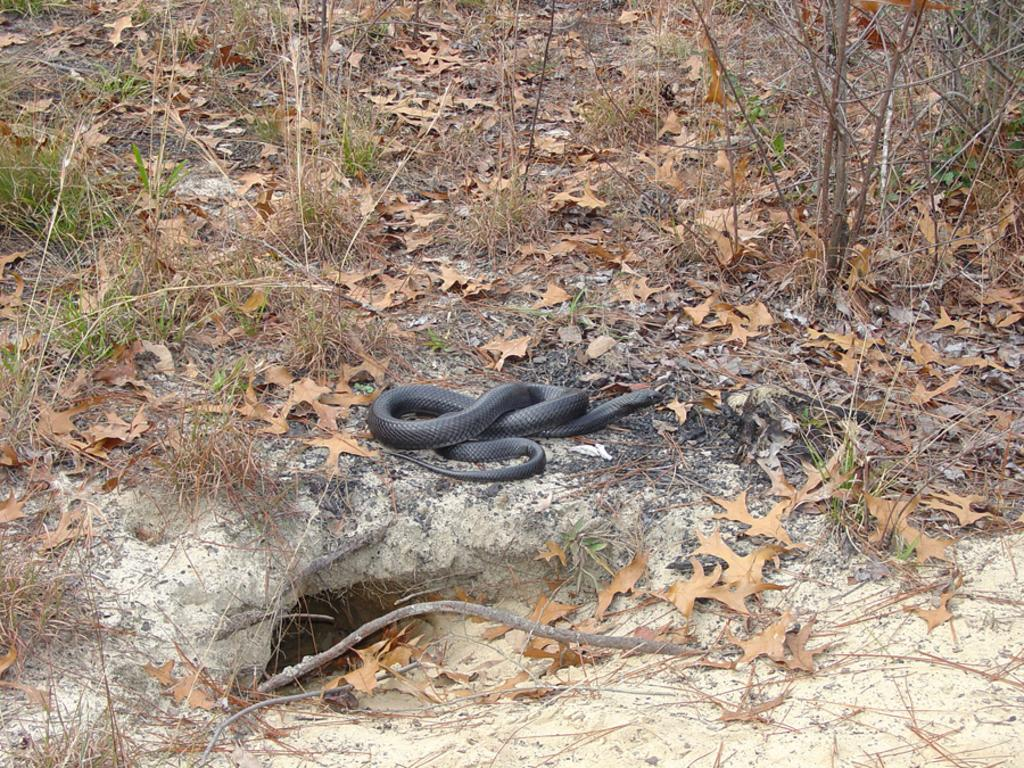What type of animal can be seen in the image? There is a snake in the image. What can be found on the ground in the image? Dried leaves are present on the ground in the image. What is visible in the background of the image? There are plants visible in the background of the image. What experience does the snake's uncle have with handling snakes? There is no information about the snake's uncle or any experience with handling snakes in the image. 